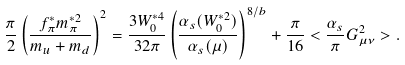<formula> <loc_0><loc_0><loc_500><loc_500>\frac { \pi } { 2 } \left ( \frac { f _ { \pi } ^ { * } m _ { \pi } ^ { * 2 } } { m _ { u } + m _ { d } } \right ) ^ { 2 } = \frac { 3 W _ { 0 } ^ { * 4 } } { 3 2 \pi } \left ( \frac { \alpha _ { s } ( W _ { 0 } ^ { * 2 } ) } { \alpha _ { s } ( \mu ) } \right ) ^ { 8 / b } + \frac { \pi } { 1 6 } < \frac { \alpha _ { s } } { \pi } G _ { \mu \nu } ^ { 2 } > .</formula> 